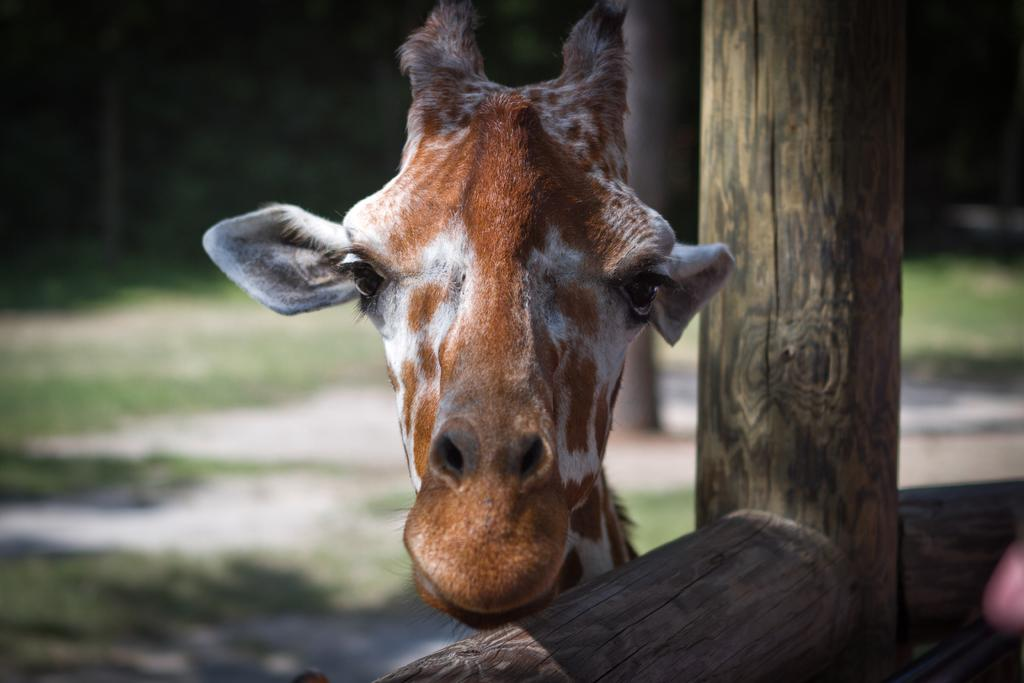What animal's face is visible in the image? There is a giraffe's face visible in the image. How is the giraffe's face framed in the image? The giraffe's face is seen through a wooden fence. What can be seen in the background of the image? There are trees and the ground visible in the background of the image. What type of star can be seen shining brightly in the image? There is no star visible in the image; it features a giraffe's face seen through a wooden fence with trees and the ground in the background. 